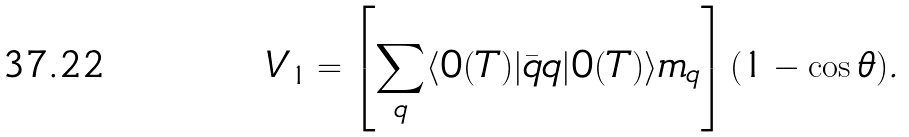Convert formula to latex. <formula><loc_0><loc_0><loc_500><loc_500>V _ { 1 } = \left [ \sum _ { q } \langle 0 ( T ) | { \bar { q } } q | 0 ( T ) \rangle m _ { q } \right ] ( 1 - \cos \theta ) .</formula> 